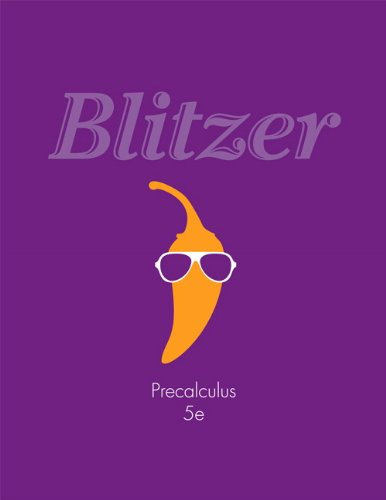Who is the author of this book?
Answer the question using a single word or phrase. Robert F. Blitzer What is the title of this book? Precalculus (5th Edition) What type of book is this? Science & Math Is this a judicial book? No 